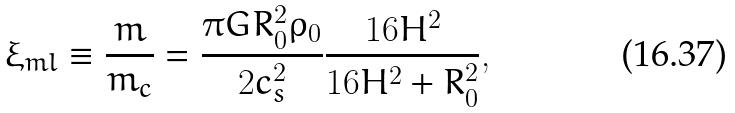<formula> <loc_0><loc_0><loc_500><loc_500>\xi _ { m l } \equiv \frac { m } { m _ { c } } = \frac { \pi G R _ { 0 } ^ { 2 } \rho _ { 0 } } { 2 c _ { s } ^ { 2 } } \frac { 1 6 H ^ { 2 } } { 1 6 H ^ { 2 } + R _ { 0 } ^ { 2 } } ,</formula> 